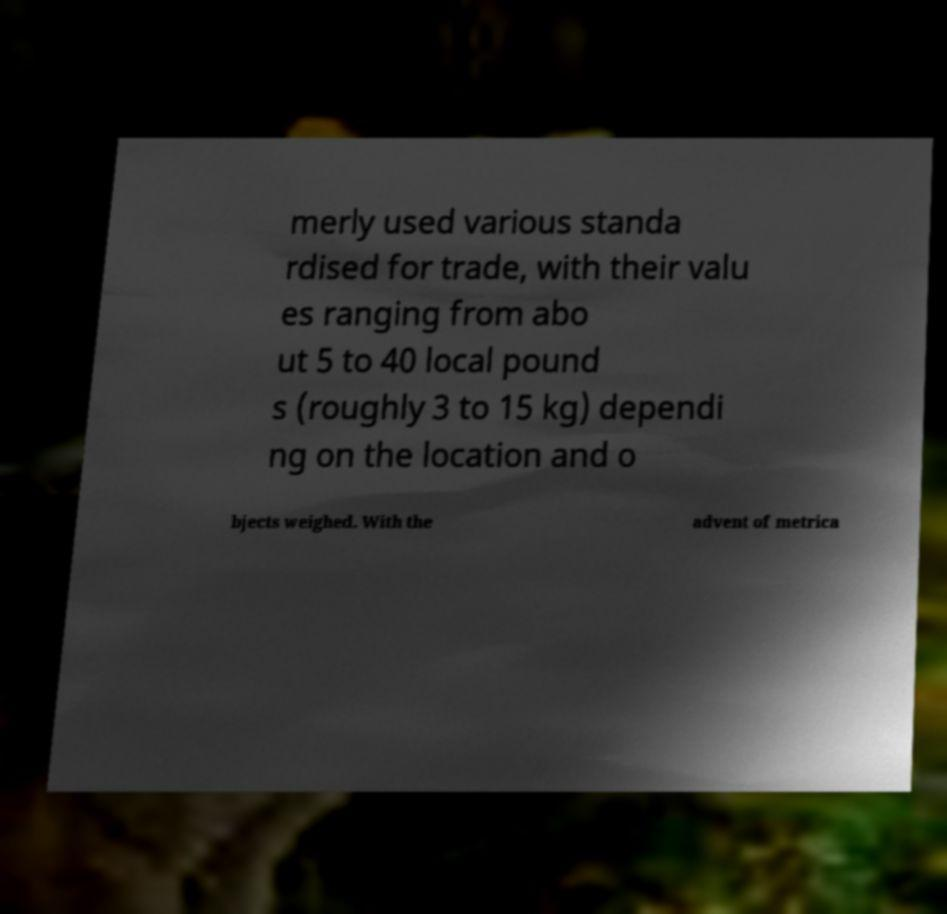Could you extract and type out the text from this image? merly used various standa rdised for trade, with their valu es ranging from abo ut 5 to 40 local pound s (roughly 3 to 15 kg) dependi ng on the location and o bjects weighed. With the advent of metrica 